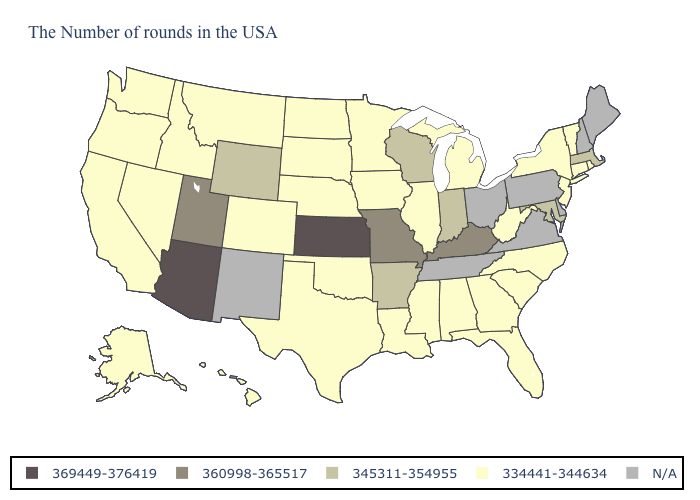What is the lowest value in the USA?
Be succinct. 334441-344634. Among the states that border North Carolina , which have the highest value?
Short answer required. South Carolina, Georgia. What is the lowest value in the USA?
Quick response, please. 334441-344634. Does the map have missing data?
Quick response, please. Yes. Among the states that border Utah , does Idaho have the highest value?
Concise answer only. No. What is the value of Wyoming?
Answer briefly. 345311-354955. What is the value of Oregon?
Quick response, please. 334441-344634. What is the lowest value in the South?
Answer briefly. 334441-344634. What is the value of West Virginia?
Concise answer only. 334441-344634. What is the highest value in the USA?
Keep it brief. 369449-376419. Name the states that have a value in the range N/A?
Short answer required. Maine, New Hampshire, Delaware, Pennsylvania, Virginia, Ohio, Tennessee, New Mexico. What is the lowest value in states that border Idaho?
Keep it brief. 334441-344634. What is the value of North Dakota?
Give a very brief answer. 334441-344634. 